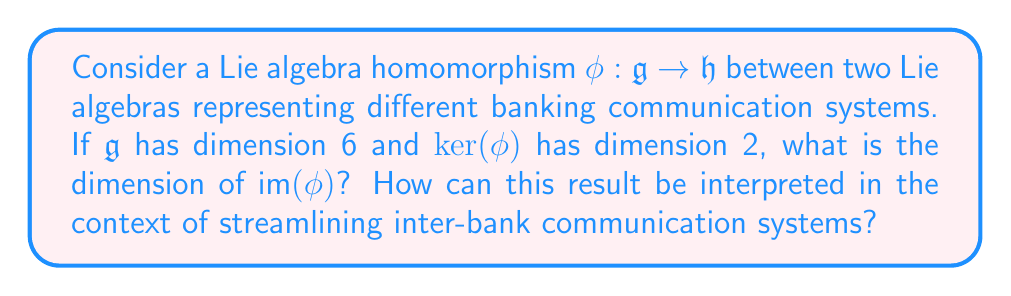Solve this math problem. To solve this problem, we'll use the fundamental theorem of linear algebra, which relates the dimensions of the kernel and image of a linear transformation. This theorem also applies to Lie algebra homomorphisms.

1) Let's define the dimensions:
   $\dim(\mathfrak{g}) = 6$
   $\dim(\ker(\phi)) = 2$

2) The fundamental theorem states:
   $\dim(\mathfrak{g}) = \dim(\ker(\phi)) + \dim(\text{im}(\phi))$

3) Substituting the known values:
   $6 = 2 + \dim(\text{im}(\phi))$

4) Solving for $\dim(\text{im}(\phi))$:
   $\dim(\text{im}(\phi)) = 6 - 2 = 4$

Interpretation in the context of inter-bank communication systems:

The Lie algebra $\mathfrak{g}$ represents the full communication system of one bank, with 6 dimensions corresponding to different aspects or channels of communication. The homomorphism $\phi$ maps this system to another bank's system $\mathfrak{h}$.

The kernel of $\phi$ represents the parts of the first bank's system that are "lost" or not translated in the communication to the second bank. In this case, it has dimension 2, meaning two aspects of the original system are not carried over.

The image of $\phi$, with dimension 4, represents the effective communication channels between the banks. This streamlined system retains 4 out of the 6 original dimensions, suggesting a simplified yet comprehensive inter-bank communication protocol.

By identifying and focusing on these 4 key dimensions, banks can create a more efficient and standardized communication system, potentially reducing complexity and improving interoperability in the banking sector.
Answer: The dimension of $\text{im}(\phi)$ is 4. 